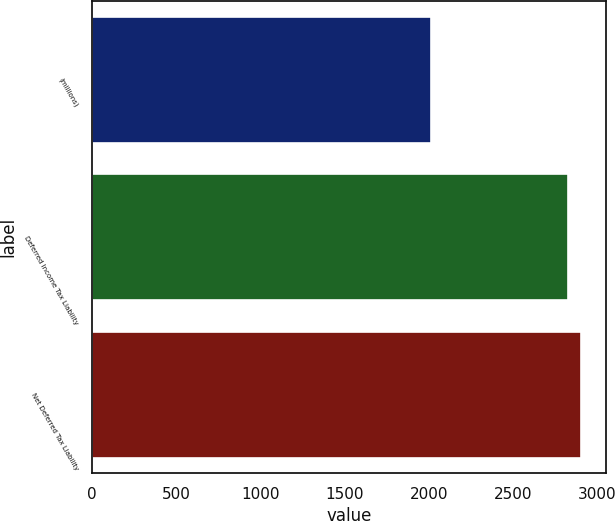Convert chart. <chart><loc_0><loc_0><loc_500><loc_500><bar_chart><fcel>(millions)<fcel>Deferred Income Tax Liability<fcel>Net Deferred Tax Liability<nl><fcel>2015<fcel>2826<fcel>2907.1<nl></chart> 